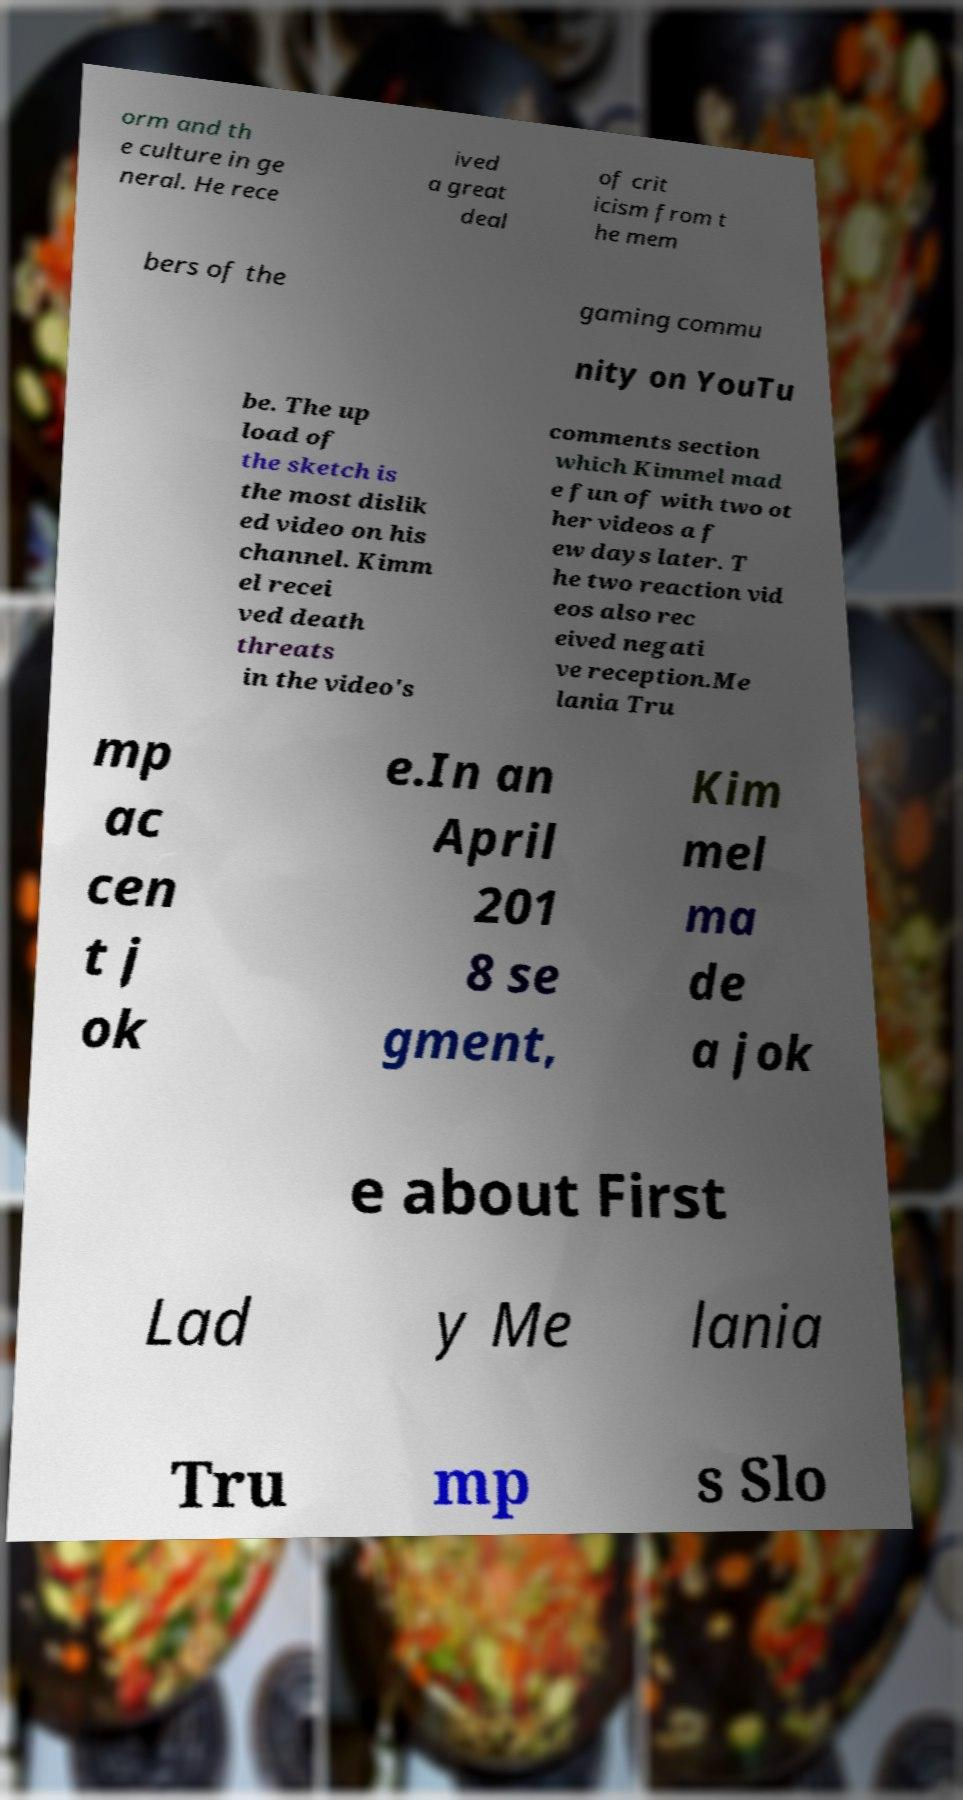For documentation purposes, I need the text within this image transcribed. Could you provide that? orm and th e culture in ge neral. He rece ived a great deal of crit icism from t he mem bers of the gaming commu nity on YouTu be. The up load of the sketch is the most dislik ed video on his channel. Kimm el recei ved death threats in the video's comments section which Kimmel mad e fun of with two ot her videos a f ew days later. T he two reaction vid eos also rec eived negati ve reception.Me lania Tru mp ac cen t j ok e.In an April 201 8 se gment, Kim mel ma de a jok e about First Lad y Me lania Tru mp s Slo 